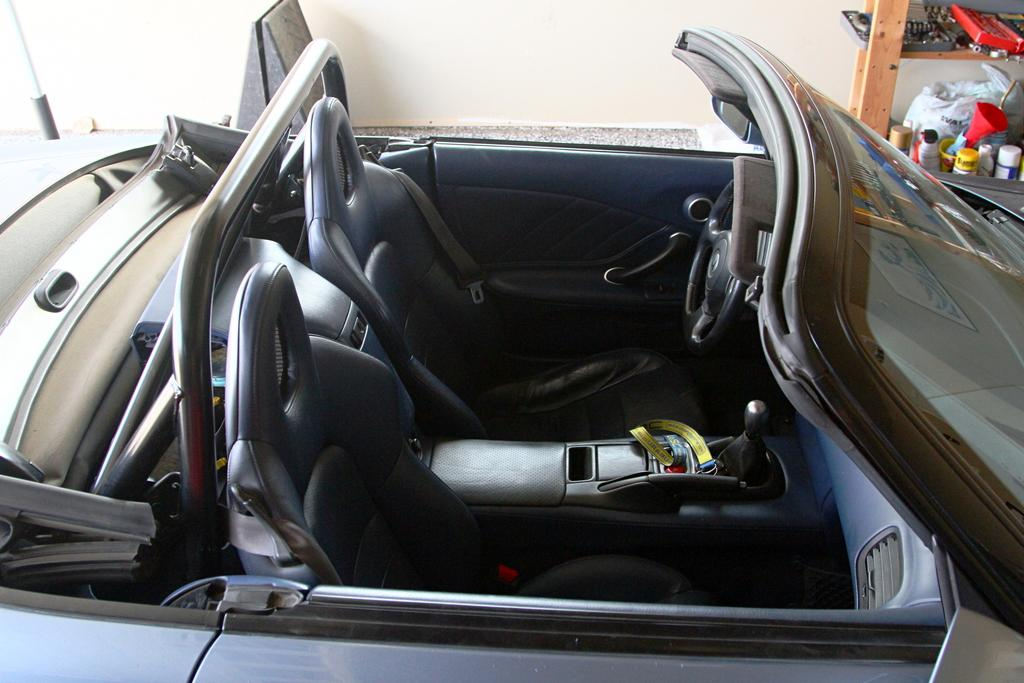What is the main subject of the image? The main subject of the image is a car. How many seats are in the car? The car has two seats. What is used for controlling the direction of the car? The car has a steering wheel. What can be seen in the background of the image? There are objects in a rack in the background of the image, and the wall is white. What type of sponge is hanging from the rearview mirror in the image? There is no sponge present in the image, and the rearview mirror is not mentioned in the provided facts. 